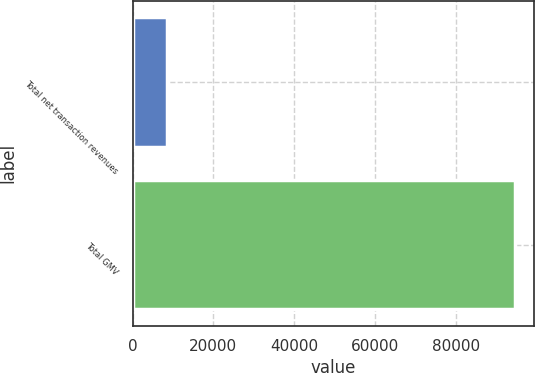<chart> <loc_0><loc_0><loc_500><loc_500><bar_chart><fcel>Total net transaction revenues<fcel>Total GMV<nl><fcel>8484<fcel>94580<nl></chart> 